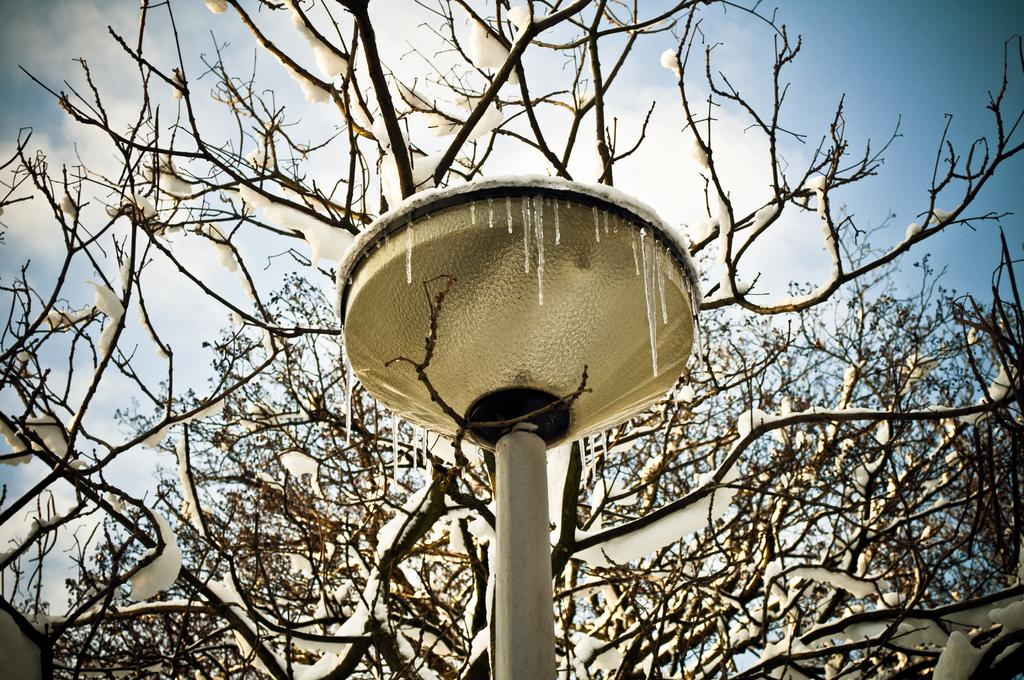What is the main object in the image? There is a pole in the image. What other natural elements can be seen in the image? There are trees in the image. What can be seen in the background of the image? The sky is visible in the background of the image. What type of cushion is being used to support the celery in the image? There is no cushion or celery present in the image. 